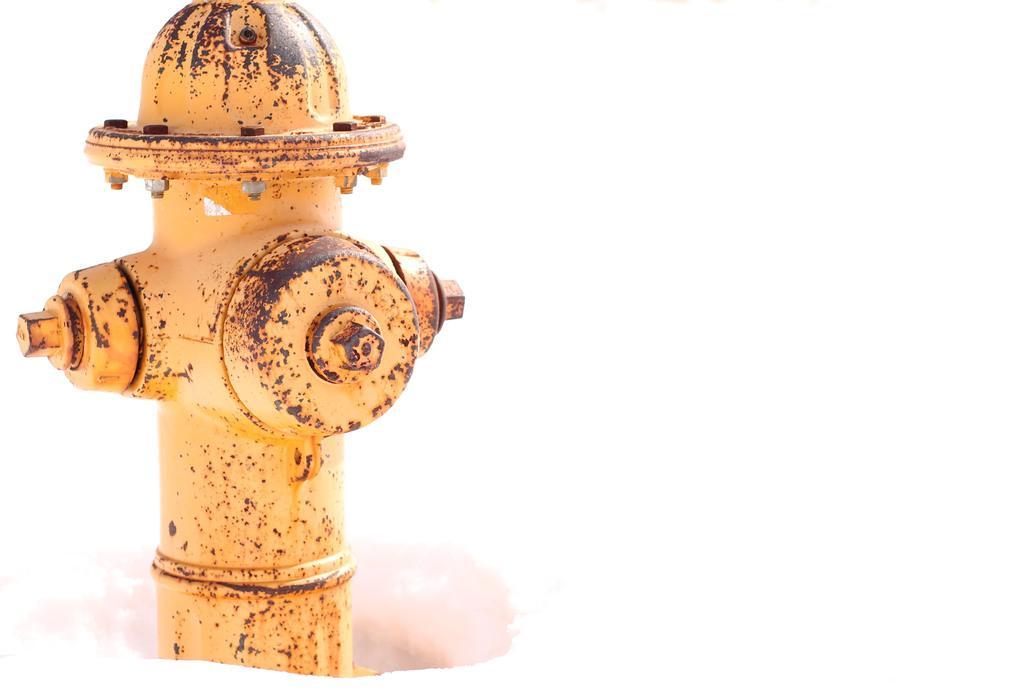In one or two sentences, can you explain what this image depicts? In this picture, we can see a yellow fire hydrant in the snow. 